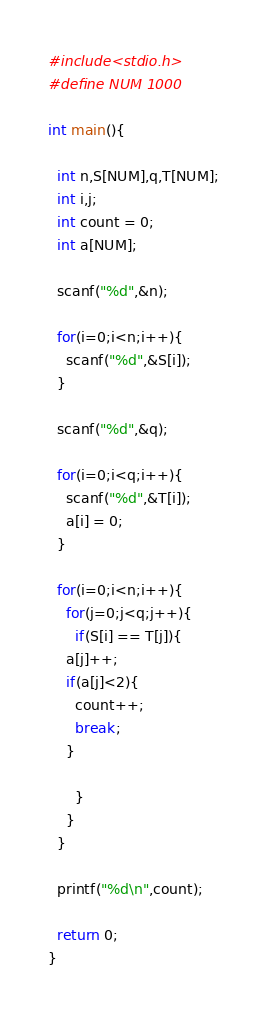Convert code to text. <code><loc_0><loc_0><loc_500><loc_500><_C_>#include<stdio.h>
#define NUM 1000

int main(){
  
  int n,S[NUM],q,T[NUM];
  int i,j;
  int count = 0;
  int a[NUM];
  
  scanf("%d",&n);
  
  for(i=0;i<n;i++){
    scanf("%d",&S[i]);
  }

  scanf("%d",&q);
  
  for(i=0;i<q;i++){
    scanf("%d",&T[i]);
    a[i] = 0;
  }    
  
  for(i=0;i<n;i++){
    for(j=0;j<q;j++){
      if(S[i] == T[j]){
	a[j]++;
	if(a[j]<2){
	  count++;
	  break;
	}
	
      }
    }
  }
  
  printf("%d\n",count);

  return 0;
}

</code> 